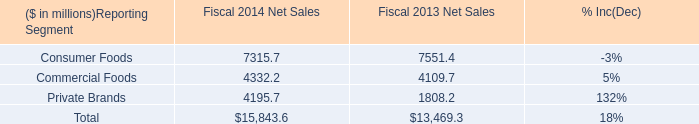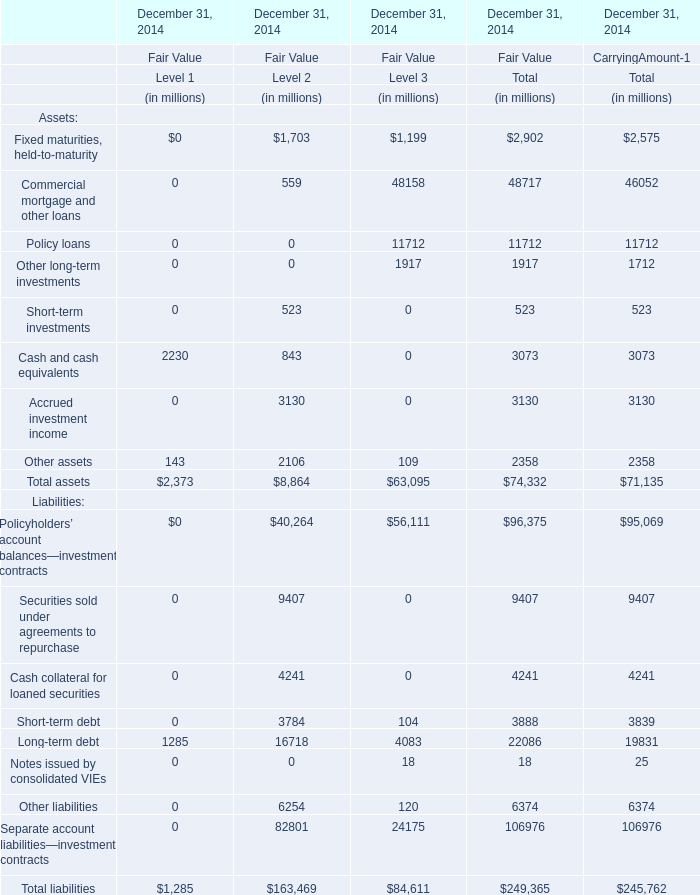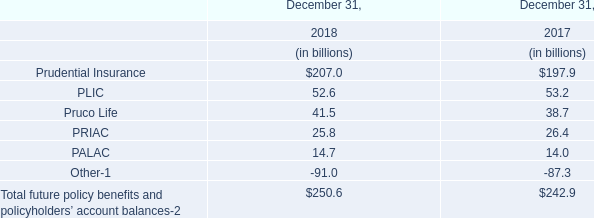In the Level where Fair Value for Total assets at December 31, 2014 is the lowest, what's the Fair Value for Other assets at December 31, 2014 ? (in million) 
Answer: 109. 